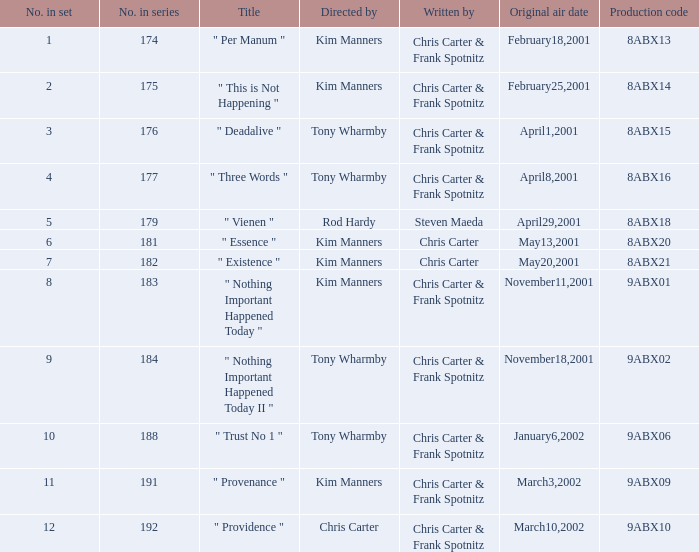Which episode number corresponds to production code 8abx15? 176.0. 